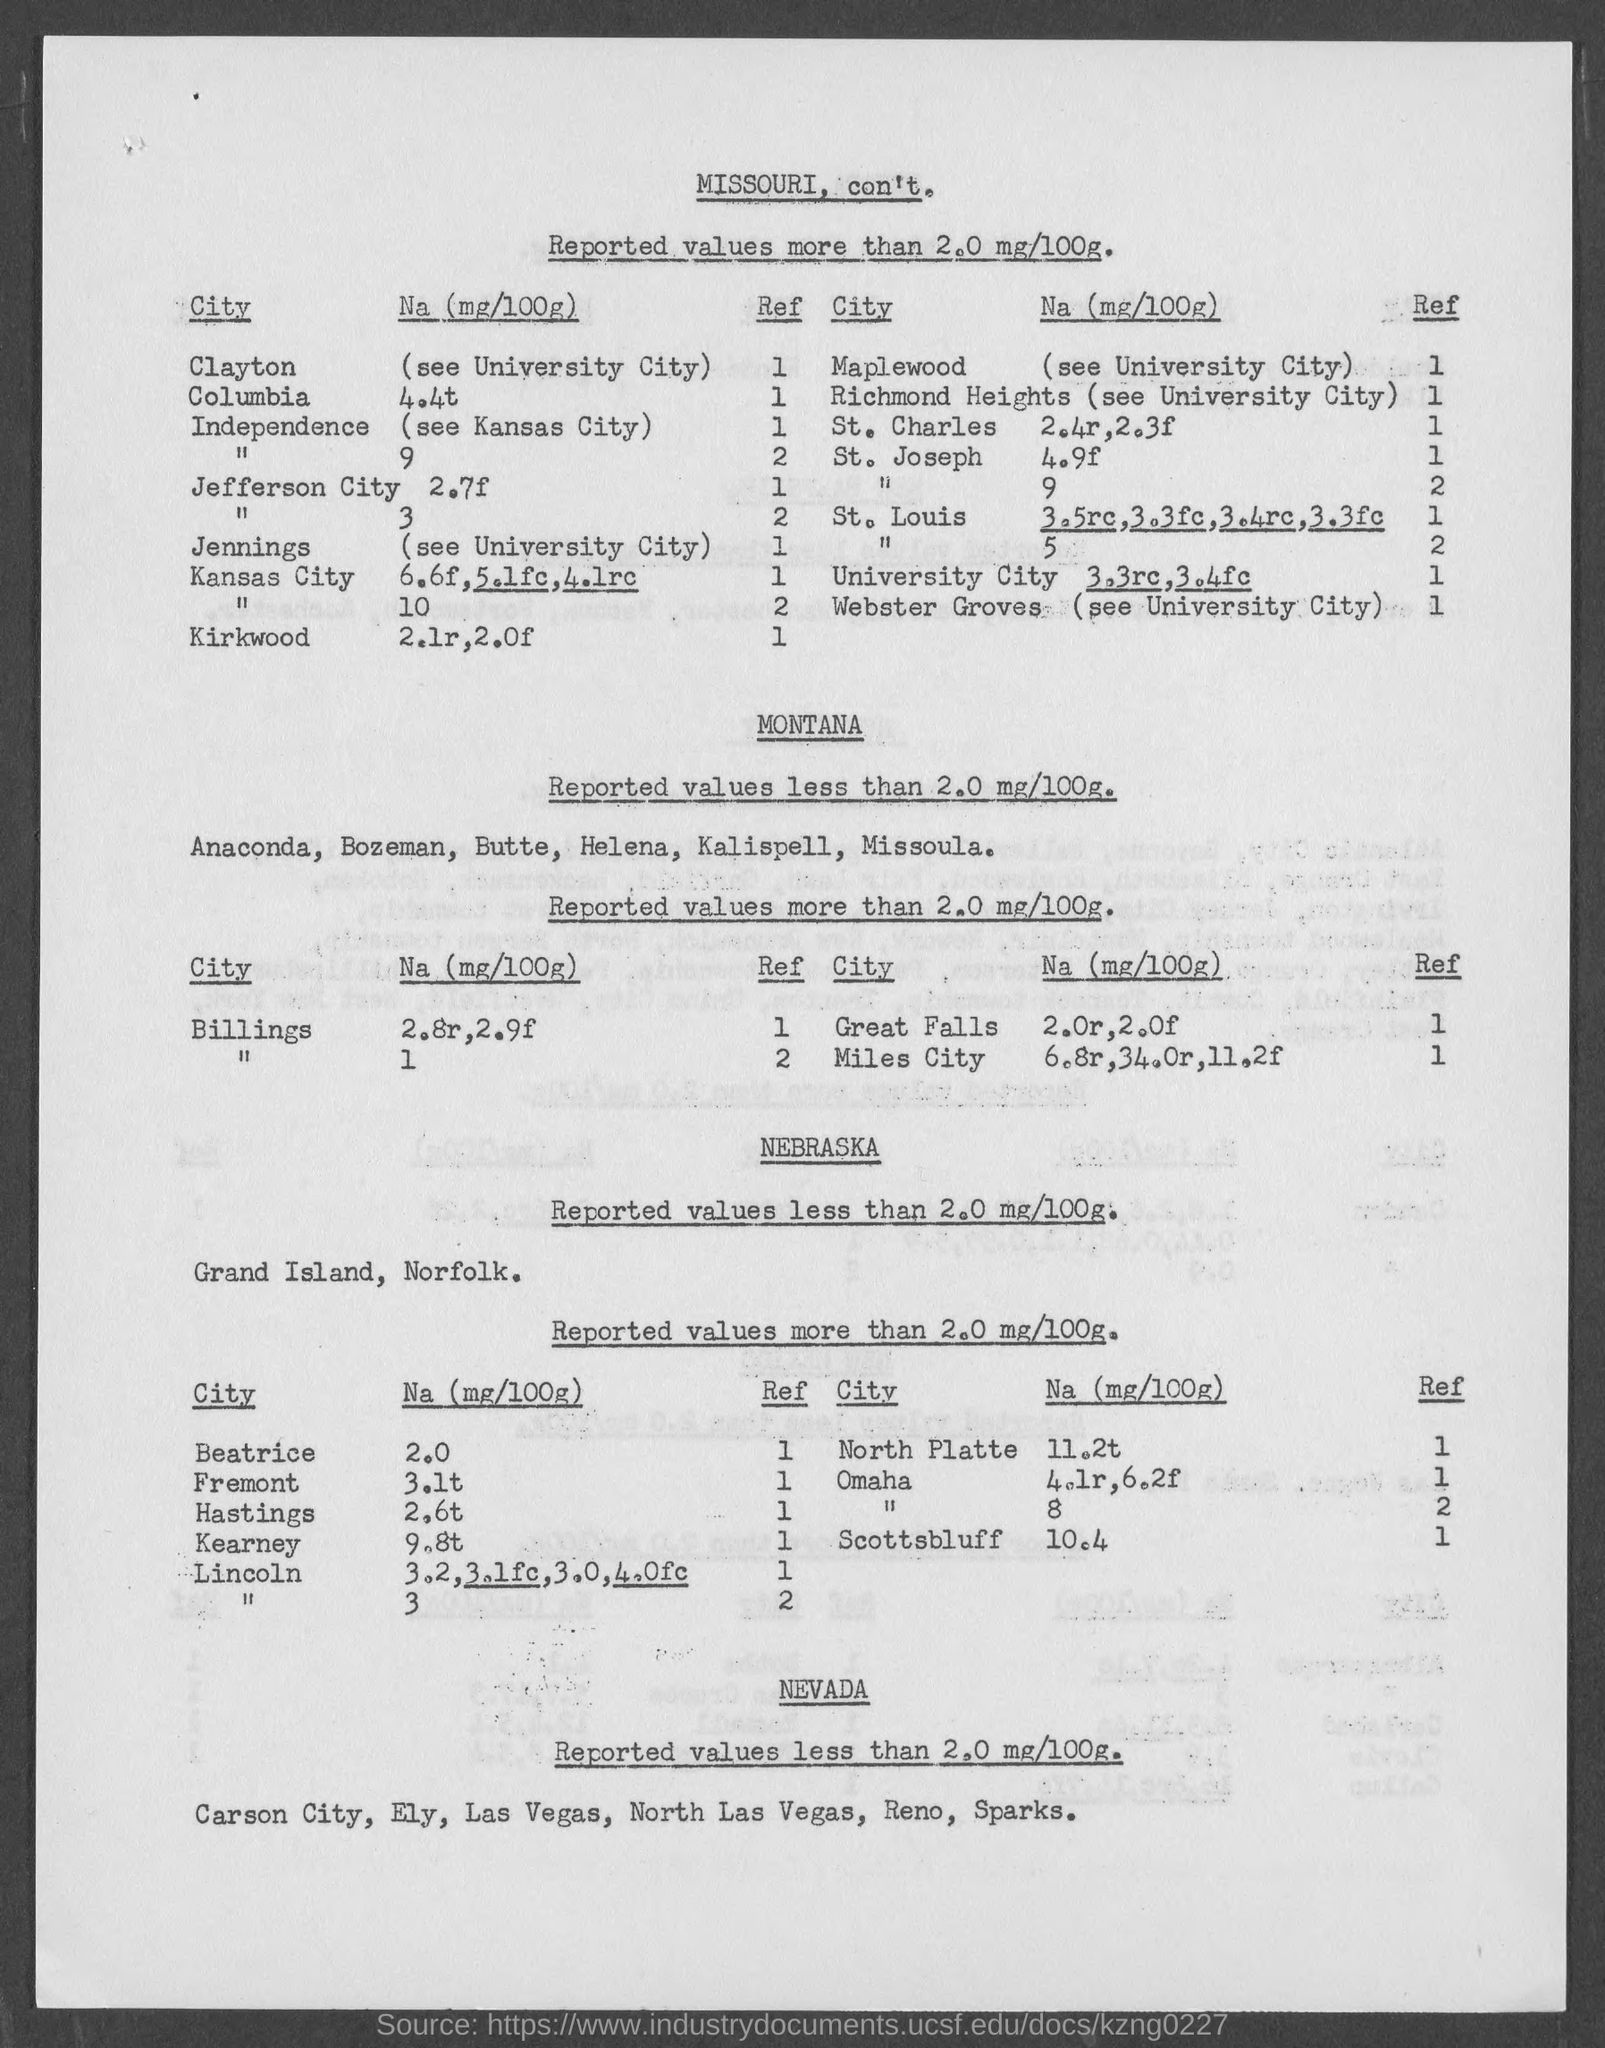What is the Na (mg/100g) for Beatrice?
Provide a short and direct response. 2.0. What is the Na (mg/100g) for Fremont?
Keep it short and to the point. 3.1t. What is the Na (mg/100g) for Hastings?
Offer a very short reply. 2.6t. What is the Na (mg/100g) for Kearney?
Give a very brief answer. 9.8t. What is the Na (mg/100g) for North Platte?
Offer a terse response. 11.2t. What is the Na (mg/100g) for Scottsbluff?
Your answer should be compact. 10.4. 